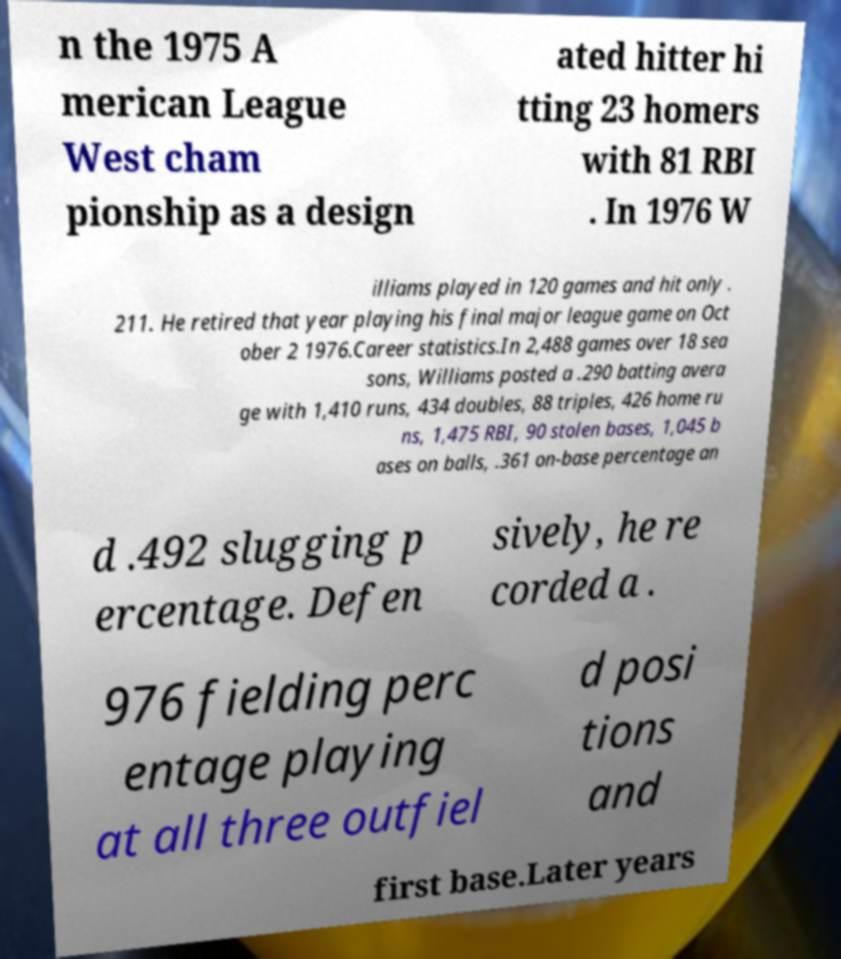Could you extract and type out the text from this image? n the 1975 A merican League West cham pionship as a design ated hitter hi tting 23 homers with 81 RBI . In 1976 W illiams played in 120 games and hit only . 211. He retired that year playing his final major league game on Oct ober 2 1976.Career statistics.In 2,488 games over 18 sea sons, Williams posted a .290 batting avera ge with 1,410 runs, 434 doubles, 88 triples, 426 home ru ns, 1,475 RBI, 90 stolen bases, 1,045 b ases on balls, .361 on-base percentage an d .492 slugging p ercentage. Defen sively, he re corded a . 976 fielding perc entage playing at all three outfiel d posi tions and first base.Later years 